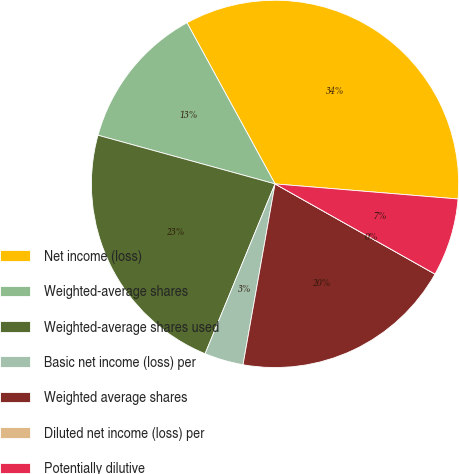Convert chart. <chart><loc_0><loc_0><loc_500><loc_500><pie_chart><fcel>Net income (loss)<fcel>Weighted-average shares<fcel>Weighted-average shares used<fcel>Basic net income (loss) per<fcel>Weighted average shares<fcel>Diluted net income (loss) per<fcel>Potentially dilutive<nl><fcel>34.27%<fcel>12.77%<fcel>23.05%<fcel>3.43%<fcel>19.62%<fcel>0.0%<fcel>6.86%<nl></chart> 